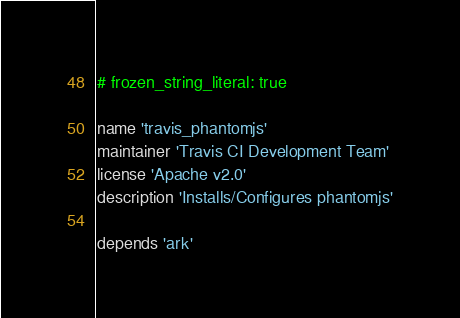<code> <loc_0><loc_0><loc_500><loc_500><_Ruby_># frozen_string_literal: true

name 'travis_phantomjs'
maintainer 'Travis CI Development Team'
license 'Apache v2.0'
description 'Installs/Configures phantomjs'

depends 'ark'
</code> 